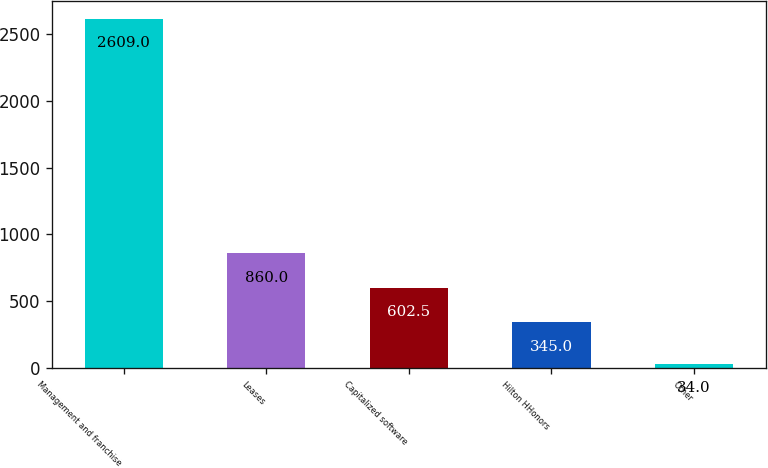<chart> <loc_0><loc_0><loc_500><loc_500><bar_chart><fcel>Management and franchise<fcel>Leases<fcel>Capitalized software<fcel>Hilton HHonors<fcel>Other<nl><fcel>2609<fcel>860<fcel>602.5<fcel>345<fcel>34<nl></chart> 